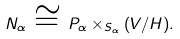Convert formula to latex. <formula><loc_0><loc_0><loc_500><loc_500>N _ { \alpha } \, \cong \, P _ { \alpha } \times _ { S _ { \alpha } } ( V / H ) .</formula> 